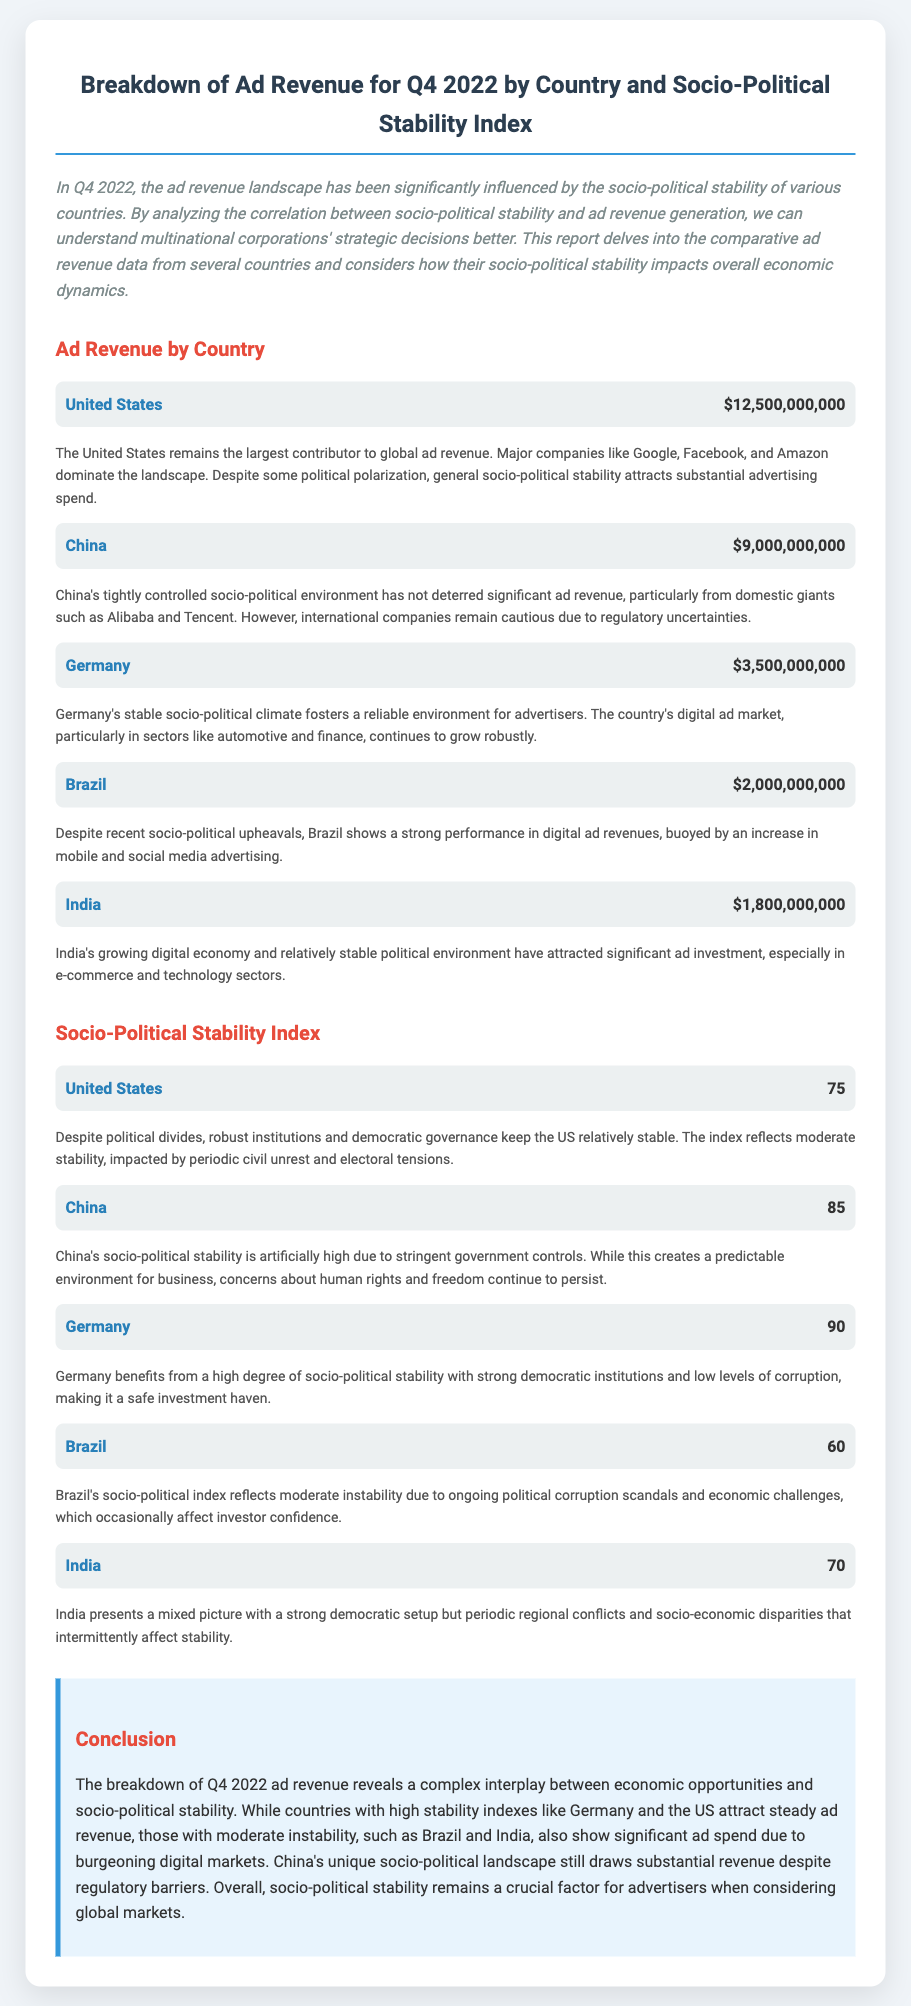What is the ad revenue for the United States? The revenue figure for the United States is listed in the document and is one of the largest among the countries.
Answer: $12,500,000,000 What is the Socio-Political Stability Index for Germany? The document provides stability indices for each country, and Germany is noted for its high stability.
Answer: 90 Which country had the lowest ad revenue? The document mentions the ad revenues for various countries, identifying the one with the smallest figure.
Answer: India What is the comment associated with Brazil's ad revenue? The document includes specific commentary for each country regarding their ad revenue and the socio-political context.
Answer: Despite recent socio-political upheavals, Brazil shows a strong performance in digital ad revenues, buoyed by an increase in mobile and social media advertising Which country has a higher stability index, China or Brazil? By comparing the stability indices provided, one can determine which country is perceived as more stable according to the data.
Answer: China What is the ad revenue for India? The revenue figure for India is provided in the document, illustrating its standing in the global market.
Answer: $1,800,000,000 Which country is noted as having significant ad investment from e-commerce? The commentary highlights the sectors attracting ad investment in India, linking it to the growing digital economy.
Answer: India What is the overall conclusion about socio-political stability and ad revenue? The document wraps up with a conclusion that summarizes the relationship between stability and revenue across countries.
Answer: Socio-political stability remains a crucial factor for advertisers when considering global markets 